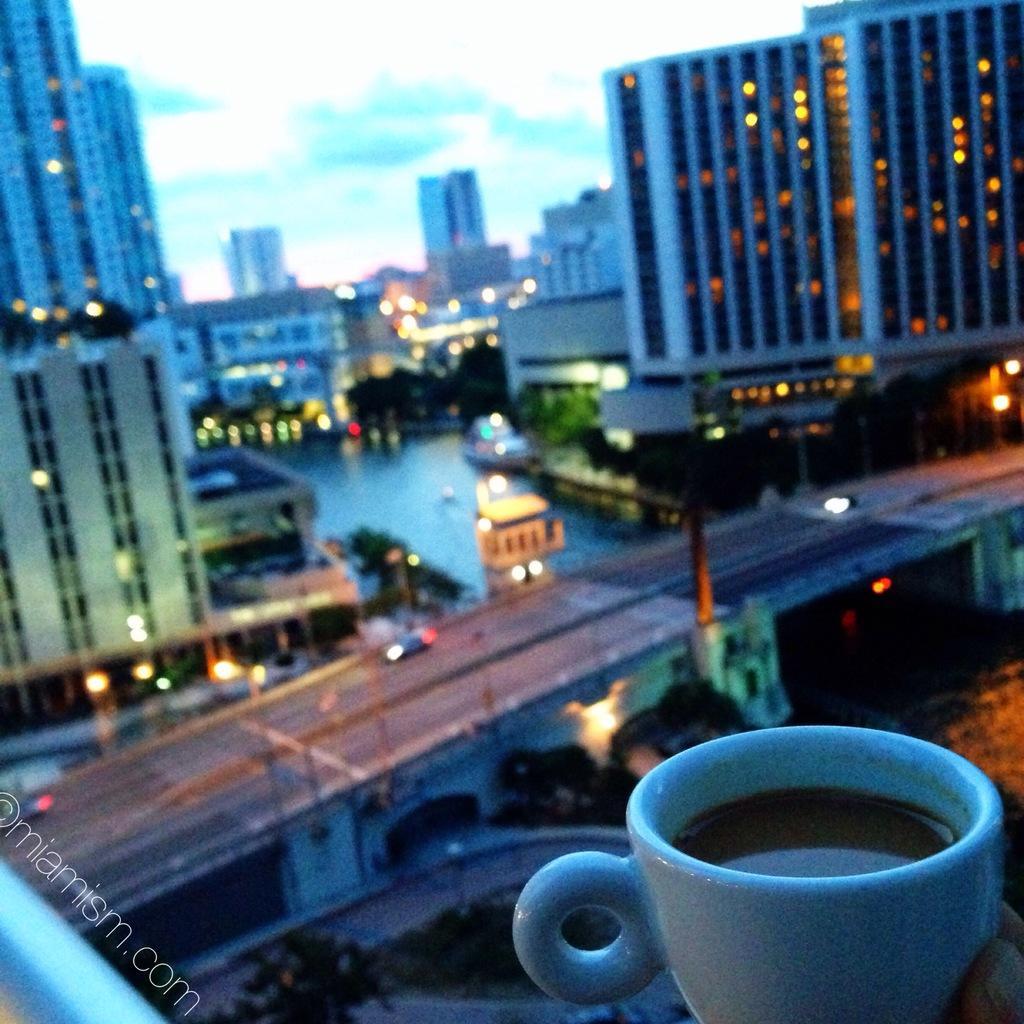In one or two sentences, can you explain what this image depicts? In the image there is a cup with some drink and behind that cup there is a clear view of the city, it has many buildings and there is a river and there is a bridge across that river, some vehicles are moving on the bridge. 